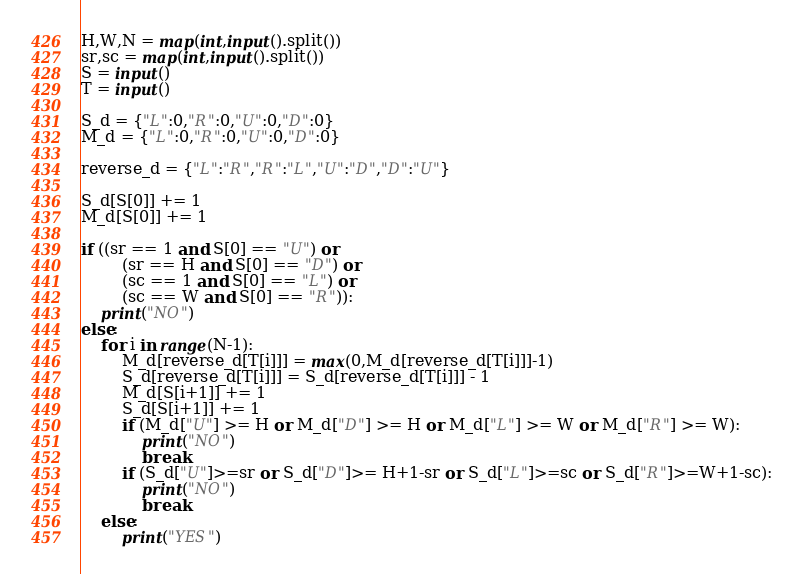<code> <loc_0><loc_0><loc_500><loc_500><_Python_>H,W,N = map(int,input().split())
sr,sc = map(int,input().split())
S = input()
T = input()

S_d = {"L":0,"R":0,"U":0,"D":0}
M_d = {"L":0,"R":0,"U":0,"D":0}

reverse_d = {"L":"R","R":"L","U":"D","D":"U"}

S_d[S[0]] += 1
M_d[S[0]] += 1

if ((sr == 1 and S[0] == "U") or
        (sr == H and S[0] == "D") or
        (sc == 1 and S[0] == "L") or
        (sc == W and S[0] == "R")):
    print("NO")
else:
    for i in range(N-1):
        M_d[reverse_d[T[i]]] = max(0,M_d[reverse_d[T[i]]]-1)
        S_d[reverse_d[T[i]]] = S_d[reverse_d[T[i]]] - 1
        M_d[S[i+1]] += 1
        S_d[S[i+1]] += 1
        if (M_d["U"] >= H or M_d["D"] >= H or M_d["L"] >= W or M_d["R"] >= W):
            print("NO")
            break
        if (S_d["U"]>=sr or S_d["D"]>= H+1-sr or S_d["L"]>=sc or S_d["R"]>=W+1-sc):
            print("NO")
            break
    else:
        print("YES")</code> 